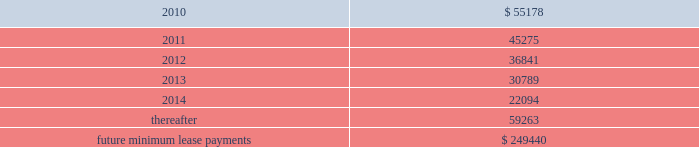Note 9 .
Commitments and contingencies operating leases we are obligated under noncancelable operating leases for corporate office space , warehouse and distribution facilities , trucks and certain equipment .
The future minimum lease commitments under these leases at december 31 , 2009 are as follows ( in thousands ) : years ending december 31: .
Rental expense for operating leases was approximately $ 57.2 million , $ 49.0 million and $ 26.6 million during the years ended december 31 , 2009 , 2008 and 2007 , respectively .
We guarantee the residual values of the majority of our truck and equipment operating leases .
The residual values decline over the lease terms to a defined percentage of original cost .
In the event the lessor does not realize the residual value when a piece of equipment is sold , we would be responsible for a portion of the shortfall .
Similarly , if the lessor realizes more than the residual value when a piece of equipment is sold , we would be paid the amount realized over the residual value .
Had we terminated all of our operating leases subject to these guarantees at december 31 , 2009 , the guaranteed residual value would have totaled approximately $ 27.8 million .
Litigation and related contingencies in december 2005 and may 2008 , ford global technologies , llc filed complaints with the international trade commission against us and others alleging that certain aftermarket parts imported into the u.s .
Infringed on ford design patents .
The parties settled these matters in april 2009 pursuant to a settlement arrangement that expires in september 2011 .
Pursuant to the settlement , we ( and our designees ) became the sole distributor in the united states of aftermarket automotive parts that correspond to ford collision parts that are covered by a united states design patent .
We have paid ford an upfront fee for these rights and will pay a royalty for each such part we sell .
The amortization of the upfront fee and the royalty expenses are reflected in cost of goods sold on the accompanying consolidated statements of income .
We also have certain other contingencies resulting from litigation , claims and other commitments and are subject to a variety of environmental and pollution control laws and regulations incident to the ordinary course of business .
We currently expect that the resolution of such contingencies will not materially affect our financial position , results of operations or cash flows .
Note 10 .
Business combinations on october 1 , 2009 , we acquired greenleaf auto recyclers , llc ( 201cgreenleaf 201d ) from ssi for $ 38.8 million , net of cash acquired .
Greenleaf is the entity through which ssi operated its late model automotive parts recycling business .
We recorded a gain on bargain purchase for the greenleaf acquisition totaling $ 4.3 million , which is .
What was the percentage change in rental expense for operating leases from 2007 to 2008? 
Computations: ((49.0 - 26.6) / 26.6)
Answer: 0.84211. 